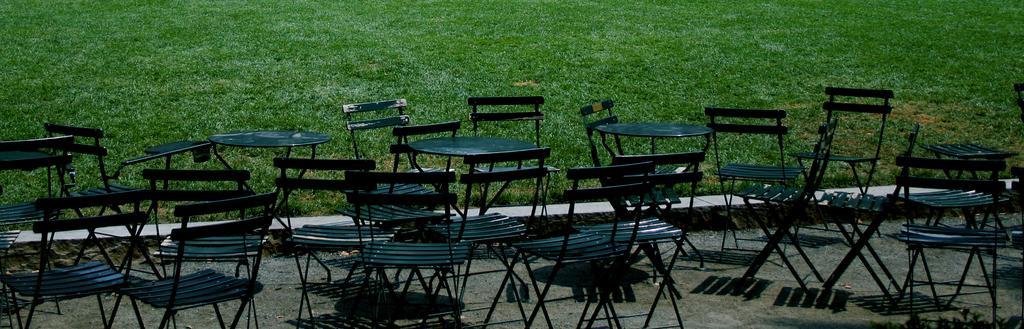In one or two sentences, can you explain what this image depicts? In the foreground of the picture there are chairs and tables. At the top there is grass. At the bottom there is soil. 